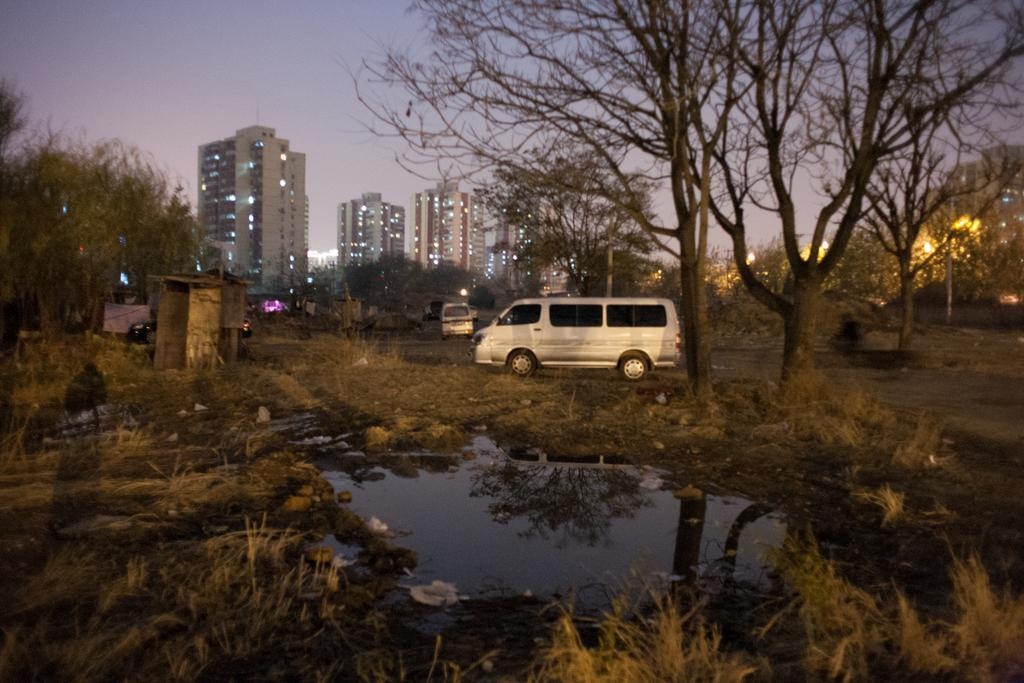What is one of the natural elements present in the image? There is water in the image. What type of vegetation can be seen in the image? There is grass in the image. What type of man-made structures are visible in the image? There are vehicles on the road and buildings in the background of the image. What other type of vegetation is present in the image? There are trees in the image. What type of hospital can be seen in the image? There is no hospital present in the image. What religious symbols can be seen in the image? There are no religious symbols present in the image. 